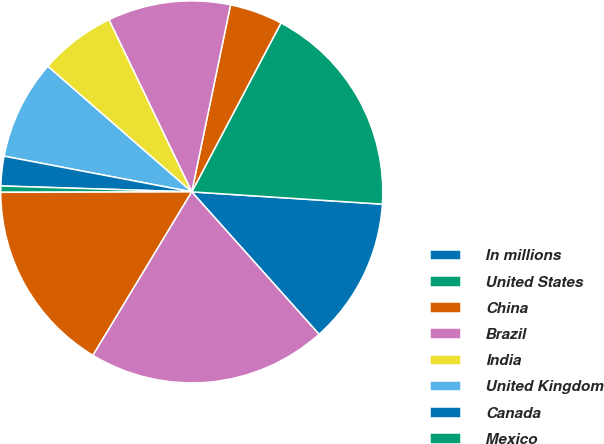Convert chart to OTSL. <chart><loc_0><loc_0><loc_500><loc_500><pie_chart><fcel>In millions<fcel>United States<fcel>China<fcel>Brazil<fcel>India<fcel>United Kingdom<fcel>Canada<fcel>Mexico<fcel>Other foreign countries<fcel>Total net sales<nl><fcel>12.37%<fcel>18.29%<fcel>4.48%<fcel>10.39%<fcel>6.45%<fcel>8.42%<fcel>2.5%<fcel>0.53%<fcel>16.31%<fcel>20.26%<nl></chart> 